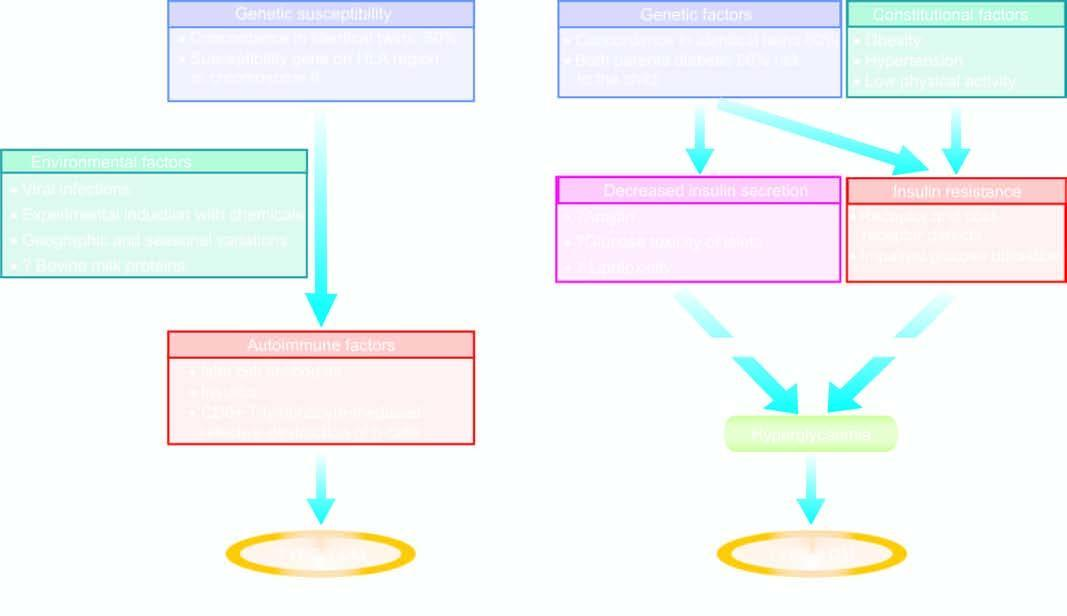s chematic mechanisms involved in pathogenesis of two main types of diabetes mellitus?
Answer the question using a single word or phrase. Yes 